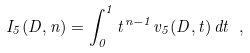<formula> <loc_0><loc_0><loc_500><loc_500>I _ { 5 } ( D , n ) = \int _ { 0 } ^ { 1 } t ^ { n - 1 } v _ { 5 } ( D , t ) \, d t \ ,</formula> 